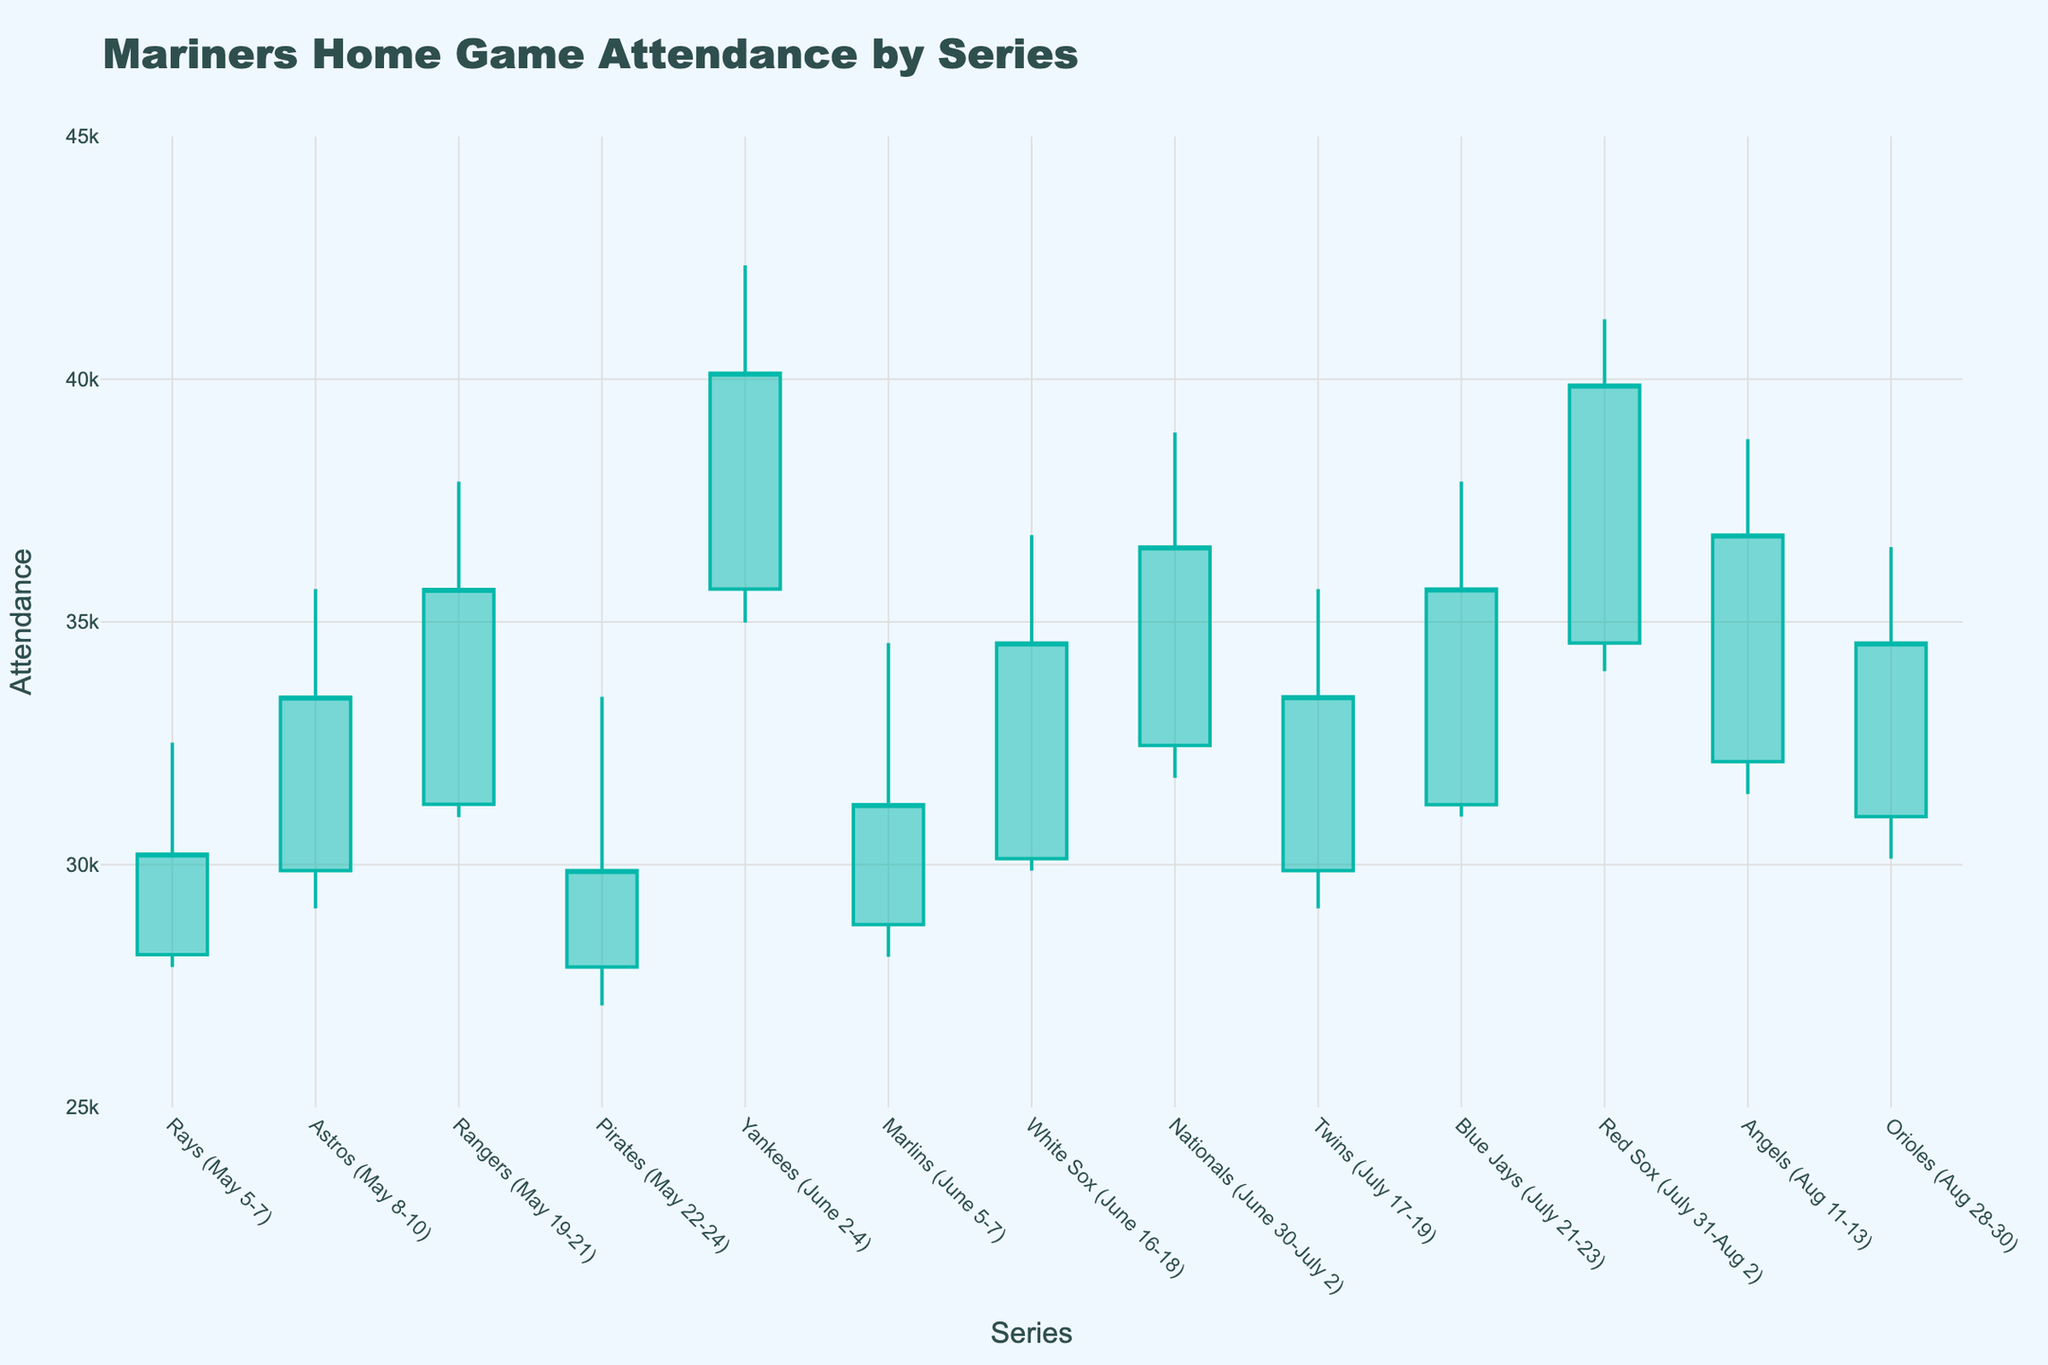What is the title of the figure? The title of the figure is displayed at the top of the chart and it provides a summary of what the chart represents. In this case, the title of the figure is "Mariners Home Game Attendance by Series".
Answer: Mariners Home Game Attendance by Series What is the highest attendance recorded in the figure? To find the highest attendance, check the 'High' values for each series and identify the maximum value. The highest recorded attendance is 42,345 during the Yankees series (June 2-4).
Answer: 42,345 Which series had the lowest opening attendance? Compare the 'Open' values for each series to identify the lowest one. The series with the lowest opening attendance is the Pirates series (May 22-24) with an opening attendance of 27,890.
Answer: Pirates (May 22-24) Between which series do we see the largest increase in closing attendance? To determine this, calculate the difference in closing attendance between consecutive series and find the maximum increase. The largest increase in closing attendance is from the Marlins series (June 5-7) to the White Sox series (June 16-18), with an increase of 3,333 (34,567 - 31,234).
Answer: Marlins to White Sox Which series had the most consistent attendance throughout the series? Consistency can be interpreted by the smallest range (High-Low). For each series, calculate the difference between the 'High' and 'Low' values. The series with the smallest range is the Orioles series (Aug 28-30) with a range of 6,420 (36,543 - 30,123).
Answer: Orioles (Aug 28-30) How many series have an opening attendance of over 30,000? Count the number of series where the 'Open' value is greater than 30,000. The series are: Rangers (May 19-21), Yankees (June 2-4), Nationals (June 30-July 2), Blue Jays (July 21-23), Red Sox (July 31-Aug 2), and Angels (Aug 11-13), making a total of 6 series.
Answer: 6 What's the average closing attendance for all the series? To find the average closing attendance, sum all 'Close' values and divide by the number of series. The total closing attendance is 435,789, and there are 13 series, so the average is 435,789 / 13 ≈ 33,522.
Answer: 33,522 Which series saw a decrease in attendance from Open to Close? Compare the 'Open' and 'Close' values for each series to identify those with a decrease. The series are the Pirates (May 22-24) and Marlins (June 5-7).
Answer: Pirates (May 22-24) and Marlins (June 5-7) What's the total range of attendance across all series? To find the total range, take the maximum 'High' value and subtract the minimum 'Low' value. The highest value is 42,345 (Yankees) and the lowest is 27,100 (Pirates), so the range is 42,345 - 27,100 = 15,245.
Answer: 15,245 